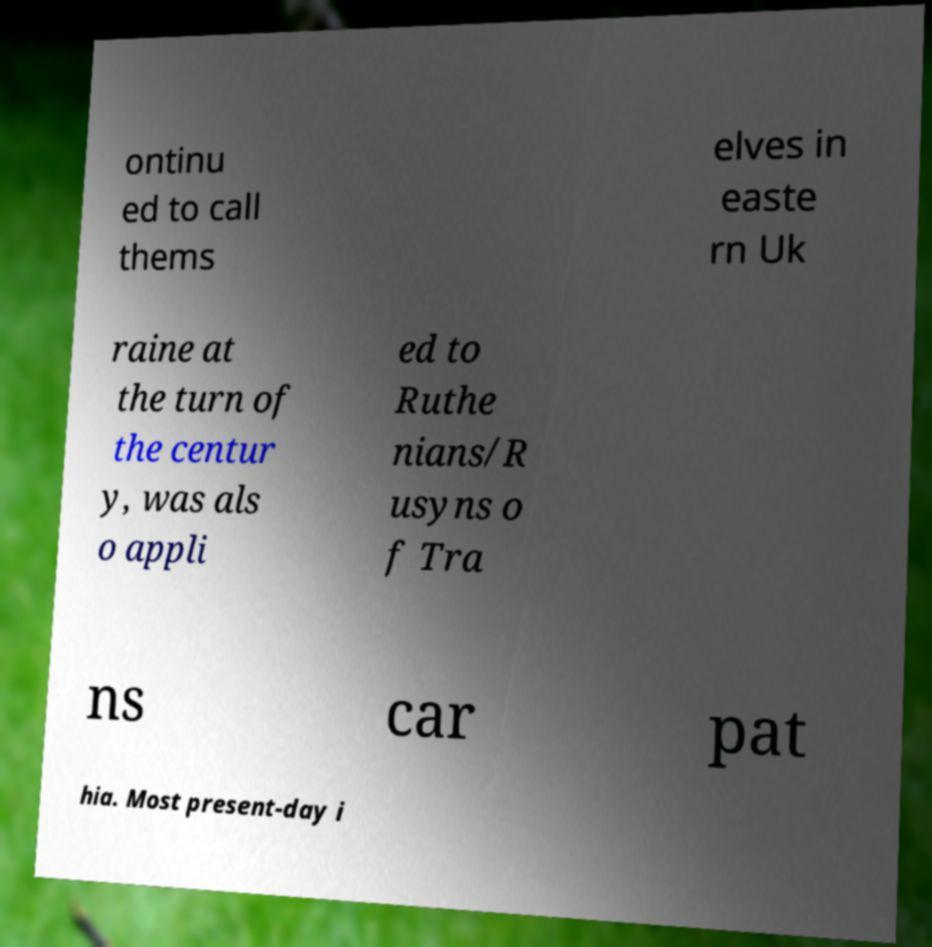Can you read and provide the text displayed in the image?This photo seems to have some interesting text. Can you extract and type it out for me? ontinu ed to call thems elves in easte rn Uk raine at the turn of the centur y, was als o appli ed to Ruthe nians/R usyns o f Tra ns car pat hia. Most present-day i 